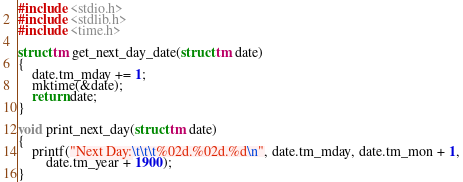<code> <loc_0><loc_0><loc_500><loc_500><_C_>#include <stdio.h>
#include <stdlib.h>
#include <time.h>

struct tm get_next_day_date(struct tm date)
{
    date.tm_mday += 1;
    mktime(&date);
    return date;
}

void print_next_day(struct tm date)
{
    printf("Next Day:\t\t\t%02d.%02d.%d\n", date.tm_mday, date.tm_mon + 1,
        date.tm_year + 1900);
}</code> 